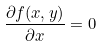Convert formula to latex. <formula><loc_0><loc_0><loc_500><loc_500>\frac { \partial f ( x , y ) } { \partial x } = 0</formula> 